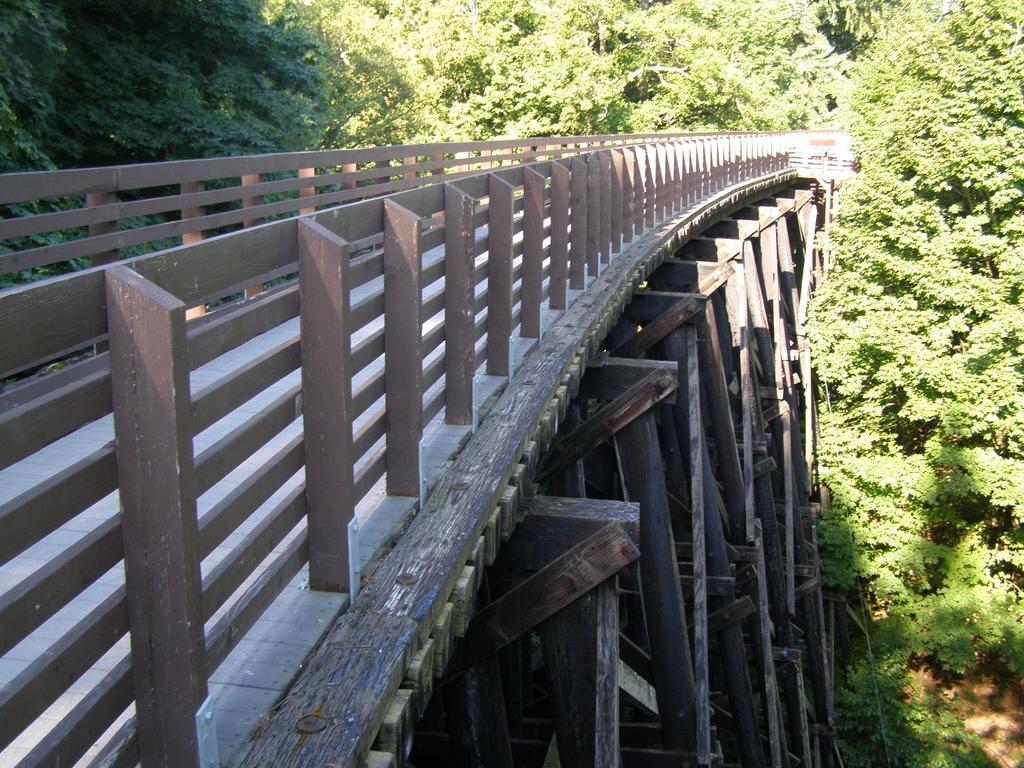In one or two sentences, can you explain what this image depicts? In this picture we can see wooden bridge, around we can see some trees. 